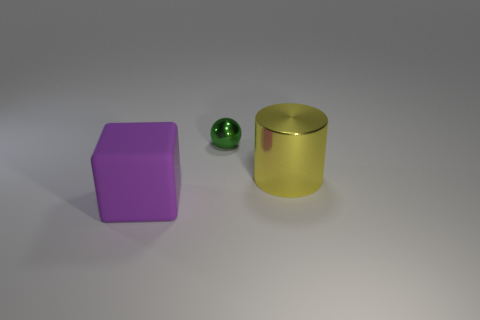Add 3 big red matte objects. How many objects exist? 6 Subtract all balls. How many objects are left? 2 Subtract all brown shiny cubes. Subtract all cylinders. How many objects are left? 2 Add 3 big objects. How many big objects are left? 5 Add 1 large green cylinders. How many large green cylinders exist? 1 Subtract 0 purple cylinders. How many objects are left? 3 